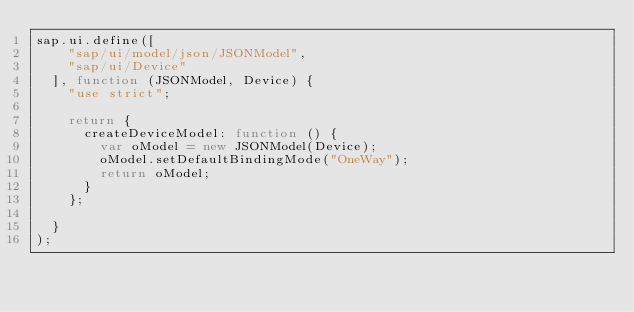<code> <loc_0><loc_0><loc_500><loc_500><_JavaScript_>sap.ui.define([
		"sap/ui/model/json/JSONModel",
		"sap/ui/Device"
	], function (JSONModel, Device) {
		"use strict";

		return {
			createDeviceModel: function () {
				var oModel = new JSONModel(Device);
				oModel.setDefaultBindingMode("OneWay");
				return oModel;
			}
		};

	}
);
</code> 